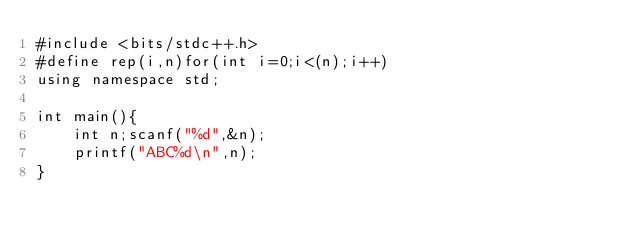<code> <loc_0><loc_0><loc_500><loc_500><_C++_>#include <bits/stdc++.h>
#define rep(i,n)for(int i=0;i<(n);i++)
using namespace std;

int main(){
	int n;scanf("%d",&n);
	printf("ABC%d\n",n);
}
</code> 